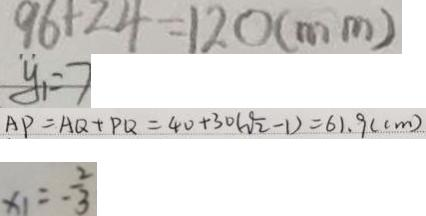Convert formula to latex. <formula><loc_0><loc_0><loc_500><loc_500>9 6 + 2 4 = 1 2 0 ( m m ) 
 y _ { 1 } = 7 
 A P = A Q + P Q = 4 0 + 3 0 ( \sqrt { 2 } - 1 ) = 6 1 . 9 ( c m ) 
 x _ { 1 } = - \frac { 2 } { 3 }</formula> 